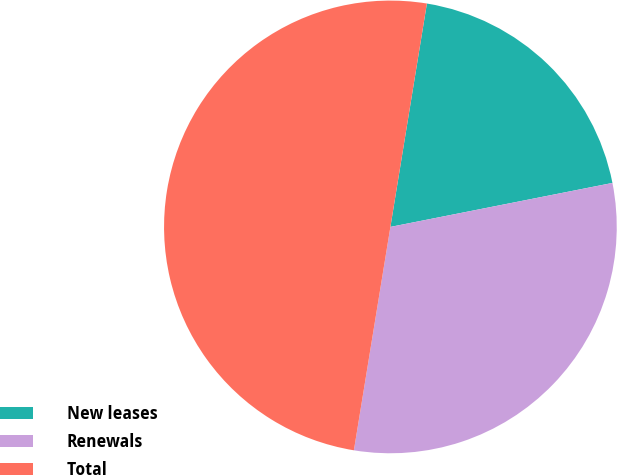Convert chart. <chart><loc_0><loc_0><loc_500><loc_500><pie_chart><fcel>New leases<fcel>Renewals<fcel>Total<nl><fcel>19.31%<fcel>30.69%<fcel>50.0%<nl></chart> 